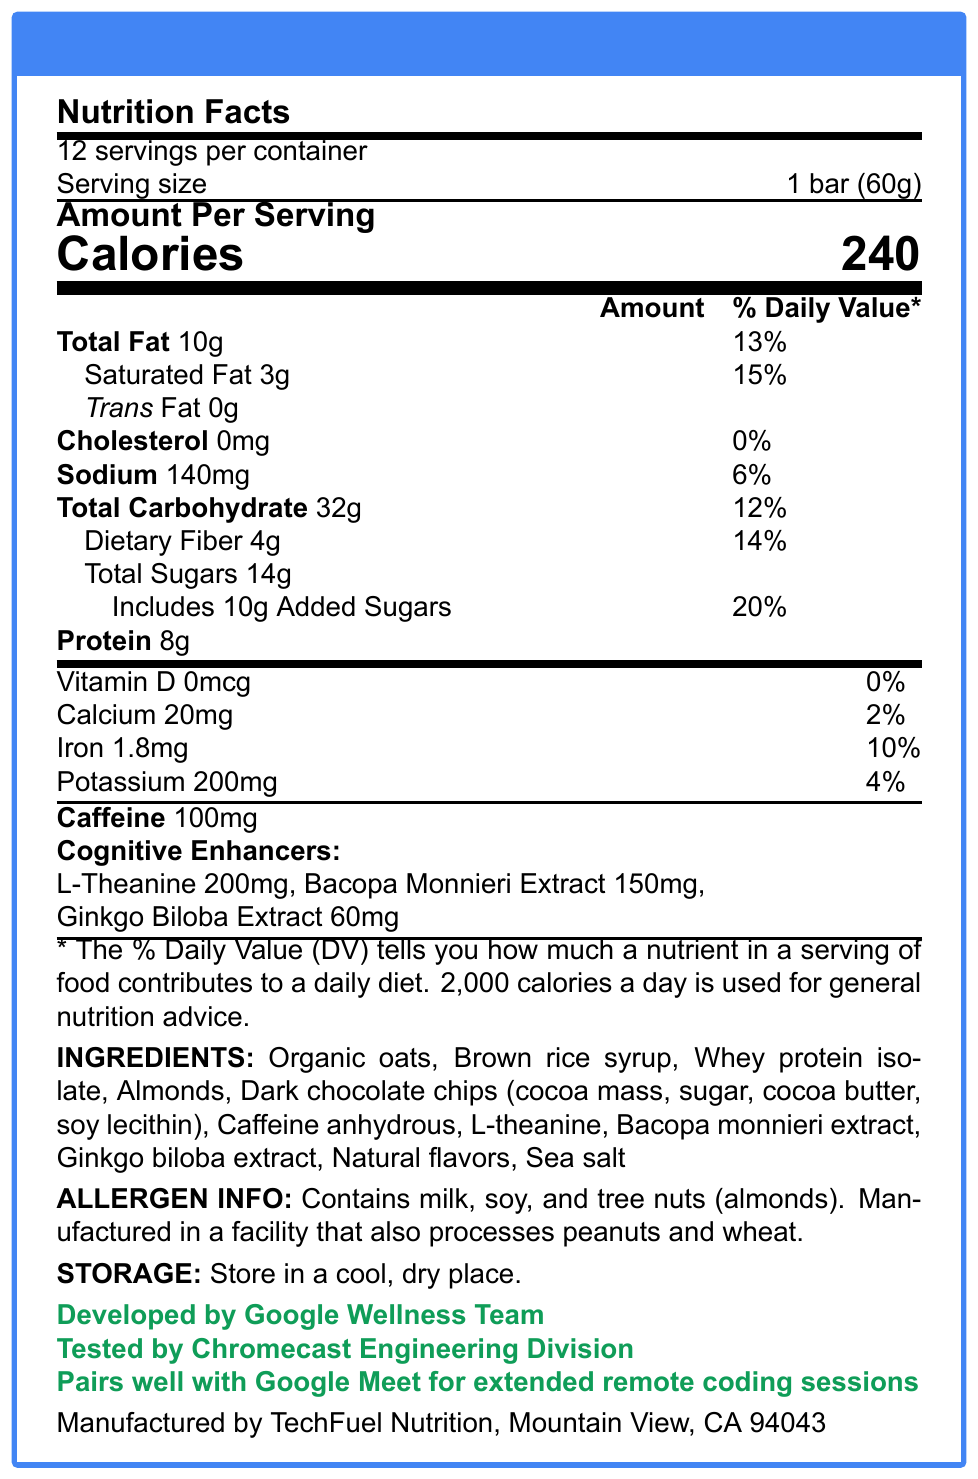what is the serving size? The serving size is explicitly mentioned as "1 bar (60g)" in the "Nutrition Facts" section.
Answer: 1 bar (60g) how many calories are in one serving? The document specifies that one serving contains 240 calories, stated under "Amount Per Serving" with large font.
Answer: 240 which vitamins and minerals are listed in the document? The document lists Vitamin D, Calcium, Iron, and Potassium in the nutritional breakdown section.
Answer: Vitamin D, Calcium, Iron, Potassium how much dietary fiber is in each serving, and what percentage of the daily value does it represent? The document indicates that each serving contains 4g of dietary fiber, which represents 14% of the daily value.
Answer: 4g, 14% how many servings are in the container? The document notes that there are 12 servings per container at the top of the "Nutrition Facts" section.
Answer: 12 what allergens are contained in the product? The allergen information section states the product contains milk, soy, and tree nuts (almonds).
Answer: Milk, soy, tree nuts (almonds) True or False: The CodeBoost Energy Bar contains Trans Fat. The document states that the amount of Trans Fat is 0g, indicating no Trans Fat is present.
Answer: False which ingredient contributes to the cognitive-enhancing properties of the energy bar? A. Dark chocolate chips B. Sea salt C. Bacopa monnieri extract D. Brown rice syrup Bacopa monnieri extract is listed under "cognitive enhancers," contributing to its cognitive-enhancing properties.
Answer: C what is the percentage of the daily value of added sugars in the bar? A. 12% B. 14% C. 20% D. 25% Added sugars constitute 20% of the daily value as listed in the document.
Answer: C is the product suitable for someone with a peanut allergy? The allergen information section states that the product is manufactured in a facility that processes peanuts, which could lead to cross-contamination.
Answer: No summarize the main idea of this document. This summary captures the key elements provided in the nutrition facts label, highlighting the major nutritional components, cognitive enhancers, and additional product-related information.
Answer: The document provides detailed nutritional information for the CodeBoost Energy Bar, including its calorie content, macronutrients, vitamins, minerals, and cognitive enhancers. It lists ingredients, allergen information, storage instructions, and additional notes about the product's development and testing by Google's teams. who is the manufacturer of the CodeBoost Energy Bar? The manufacturer's information is clearly listed at the bottom of the document.
Answer: TechFuel Nutrition, Mountain View, CA 94043 how much protein does one bar contain? The document indicates that one bar contains 8g of protein in the "Amount Per Serving" information.
Answer: 8g which Google team developed the CodeBoost Energy Bar? It is explicitly stated that the CodeBoost Energy Bar was developed by the Google Wellness Team.
Answer: Google Wellness Team how much caffeine is in one serving of the CodeBoost Energy Bar? The document specifies that each serving contains 100mg of caffeine.
Answer: 100mg what is the primary purpose of the cognitive enhancers in the energy bar? The document mentions that the bar is designed for long coding sessions, suggesting that the cognitive enhancers are meant to improve focus and cognitive function during these periods.
Answer: To aid in long coding sessions how many grams of total carbohydrates are in each serving? The Total Carbohydrate content is listed as 32g per serving in the nutritional breakdown section.
Answer: 32g describe the storage instructions for the CodeBoost Energy Bar. The storage instructions are explicitly stated as "Store in a cool, dry place" in the document.
Answer: Store in a cool, dry place. if someone is looking to increase their dietary calcium intake significantly, is the CodeBoost Energy Bar a good option? The CodeBoost Energy Bar only provides 2% of the daily value for calcium, which is relatively low for those looking to significantly increase their dietary calcium intake.
Answer: No what is the recommended use of the CodeBoost Energy Bar by the document? The document highlights that the bar pairs well with Google Meet for extended remote coding sessions, indicating it is intended to support long periods of focused work.
Answer: Pairs well with Google Meet for extended remote coding sessions 